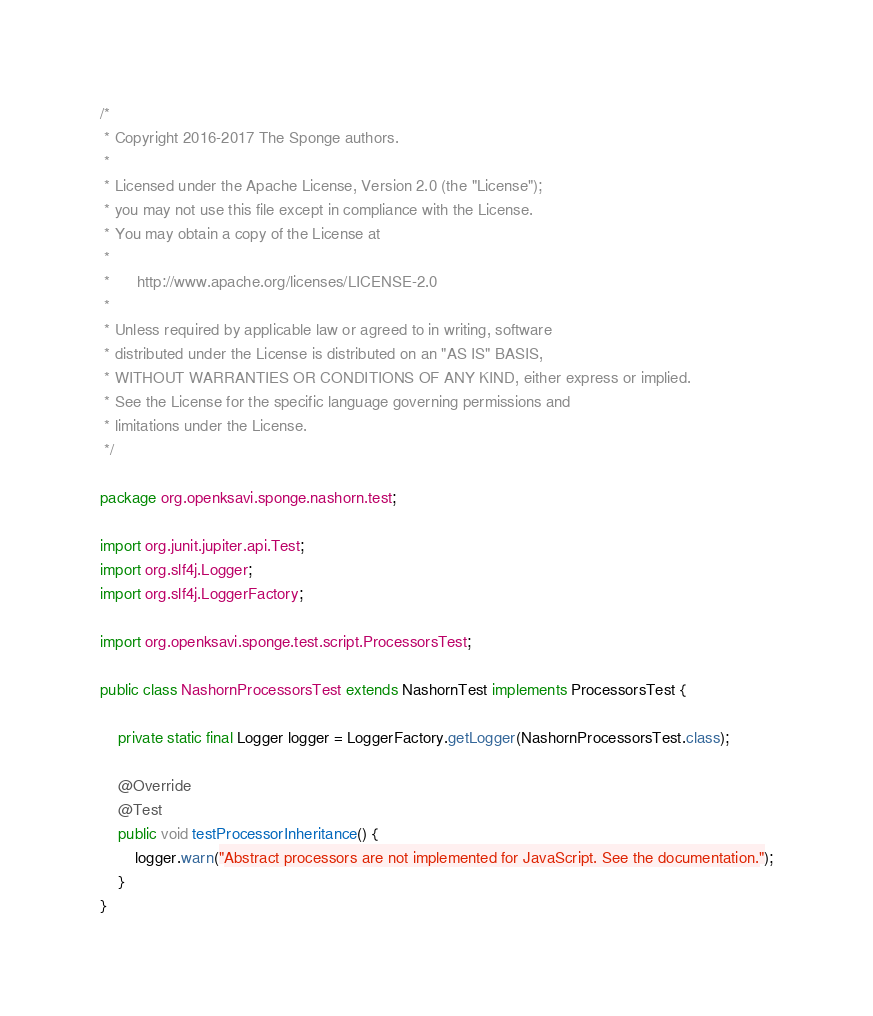Convert code to text. <code><loc_0><loc_0><loc_500><loc_500><_Java_>/*
 * Copyright 2016-2017 The Sponge authors.
 *
 * Licensed under the Apache License, Version 2.0 (the "License");
 * you may not use this file except in compliance with the License.
 * You may obtain a copy of the License at
 *
 *      http://www.apache.org/licenses/LICENSE-2.0
 *
 * Unless required by applicable law or agreed to in writing, software
 * distributed under the License is distributed on an "AS IS" BASIS,
 * WITHOUT WARRANTIES OR CONDITIONS OF ANY KIND, either express or implied.
 * See the License for the specific language governing permissions and
 * limitations under the License.
 */

package org.openksavi.sponge.nashorn.test;

import org.junit.jupiter.api.Test;
import org.slf4j.Logger;
import org.slf4j.LoggerFactory;

import org.openksavi.sponge.test.script.ProcessorsTest;

public class NashornProcessorsTest extends NashornTest implements ProcessorsTest {

    private static final Logger logger = LoggerFactory.getLogger(NashornProcessorsTest.class);

    @Override
    @Test
    public void testProcessorInheritance() {
        logger.warn("Abstract processors are not implemented for JavaScript. See the documentation.");
    }
}
</code> 